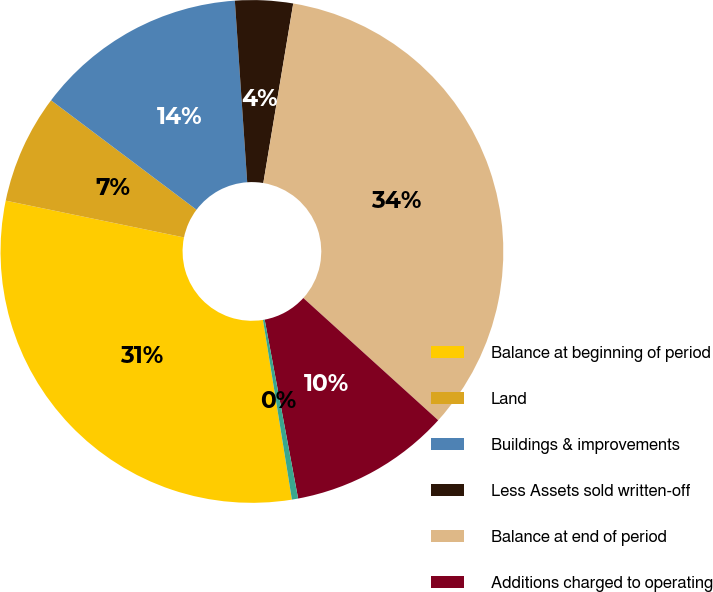Convert chart to OTSL. <chart><loc_0><loc_0><loc_500><loc_500><pie_chart><fcel>Balance at beginning of period<fcel>Land<fcel>Buildings & improvements<fcel>Less Assets sold written-off<fcel>Balance at end of period<fcel>Additions charged to operating<fcel>Less Accumulated depreciation<nl><fcel>30.78%<fcel>7.03%<fcel>13.65%<fcel>3.71%<fcel>34.09%<fcel>10.34%<fcel>0.4%<nl></chart> 